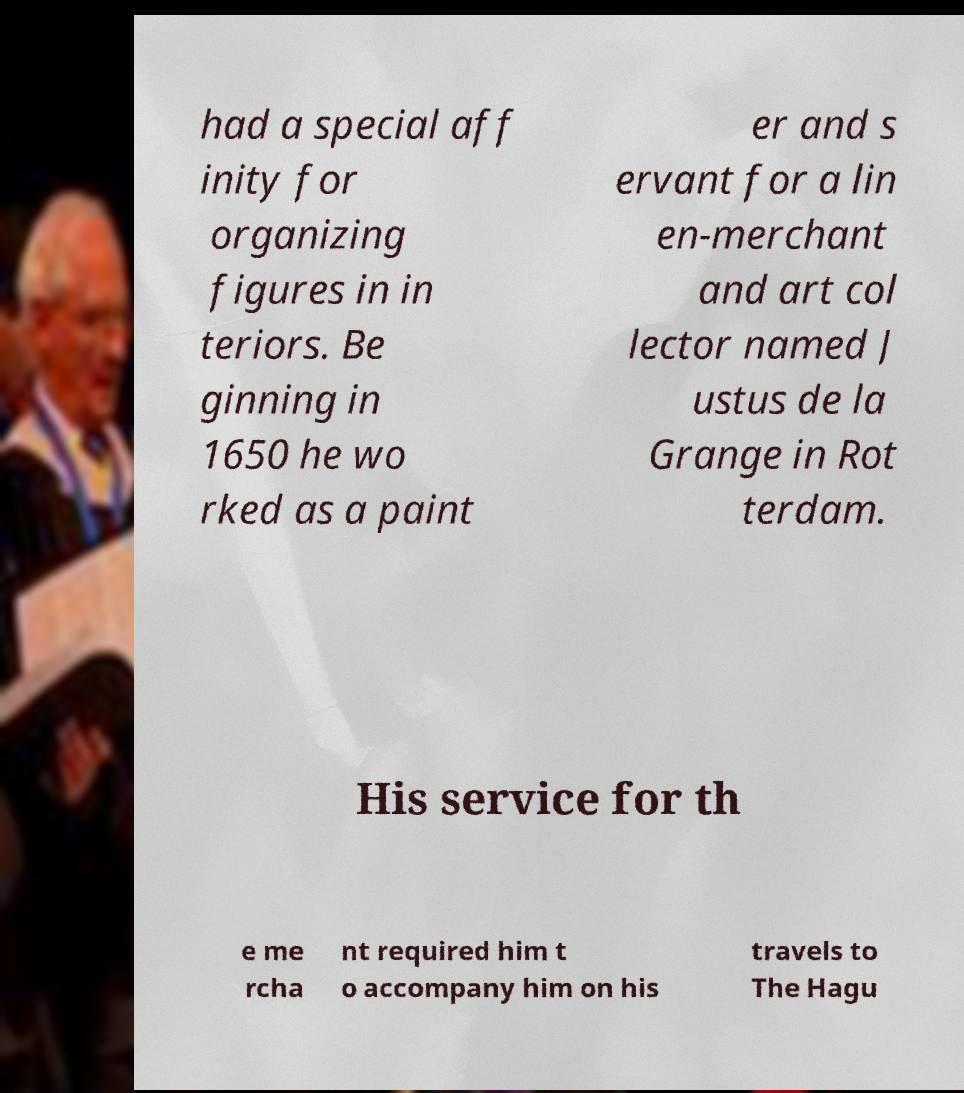Please identify and transcribe the text found in this image. had a special aff inity for organizing figures in in teriors. Be ginning in 1650 he wo rked as a paint er and s ervant for a lin en-merchant and art col lector named J ustus de la Grange in Rot terdam. His service for th e me rcha nt required him t o accompany him on his travels to The Hagu 